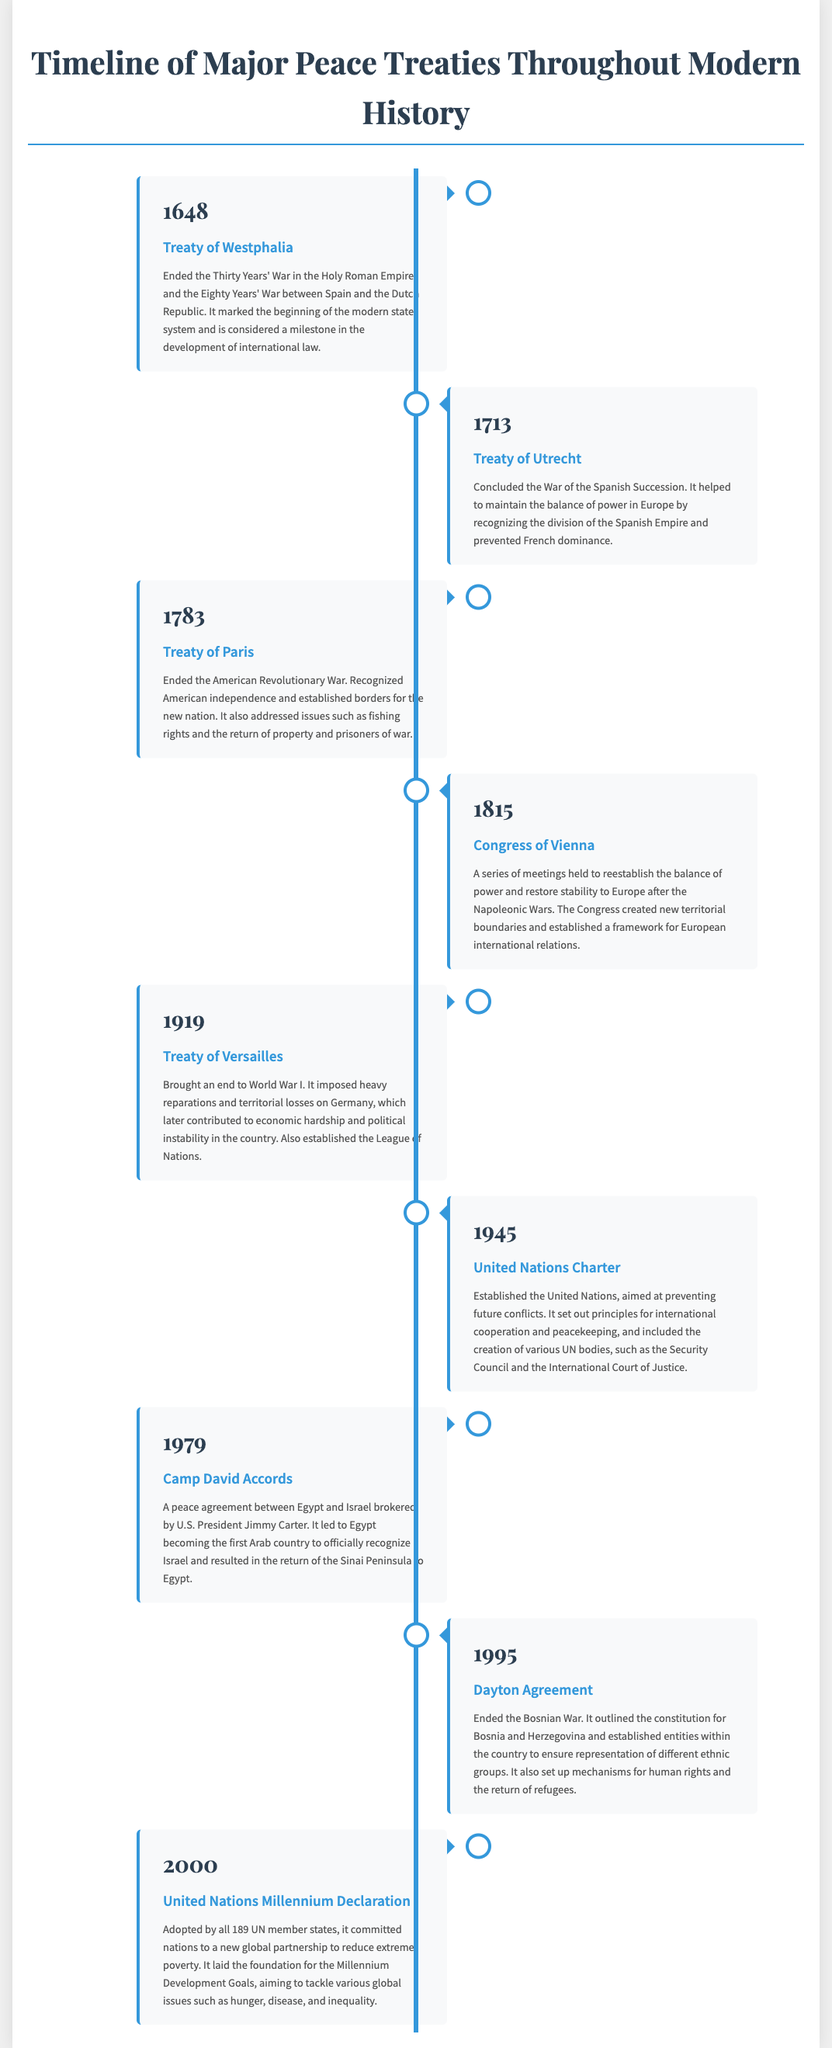What year was the Treaty of Westphalia signed? The Treaty of Westphalia is listed under the year 1648 in the document.
Answer: 1648 What was the main outcome of the Treaty of Versailles? The document states that the Treaty of Versailles brought an end to World War I and imposed heavy reparations and territorial losses on Germany.
Answer: Ended World War I Which treaty recognized American independence? The Treaty of Paris is highlighted as the agreement that ended the American Revolutionary War and recognized American independence.
Answer: Treaty of Paris What significant event did the United Nations Charter establish? The document mentions that the United Nations Charter established the United Nations aimed at preventing future conflicts.
Answer: United Nations Which treaty involved a peace agreement between Egypt and Israel? The Camp David Accords are specified as the peace agreement between Egypt and Israel.
Answer: Camp David Accords How many treaties are listed in the timeline? The document outlines a total of eight major peace treaties.
Answer: Eight What organization was established by the United Nations Charter? The document notes that the United Nations Charter established the United Nations, which includes various UN bodies.
Answer: United Nations What is the purpose of the United Nations Millennium Declaration? The document states that the United Nations Millennium Declaration committed nations to a new global partnership to reduce extreme poverty.
Answer: Reduce extreme poverty What does the Dayton Agreement represent? The document describes the Dayton Agreement as ending the Bosnian War and outlining the constitution for Bosnia and Herzegovina.
Answer: Ended the Bosnian War 